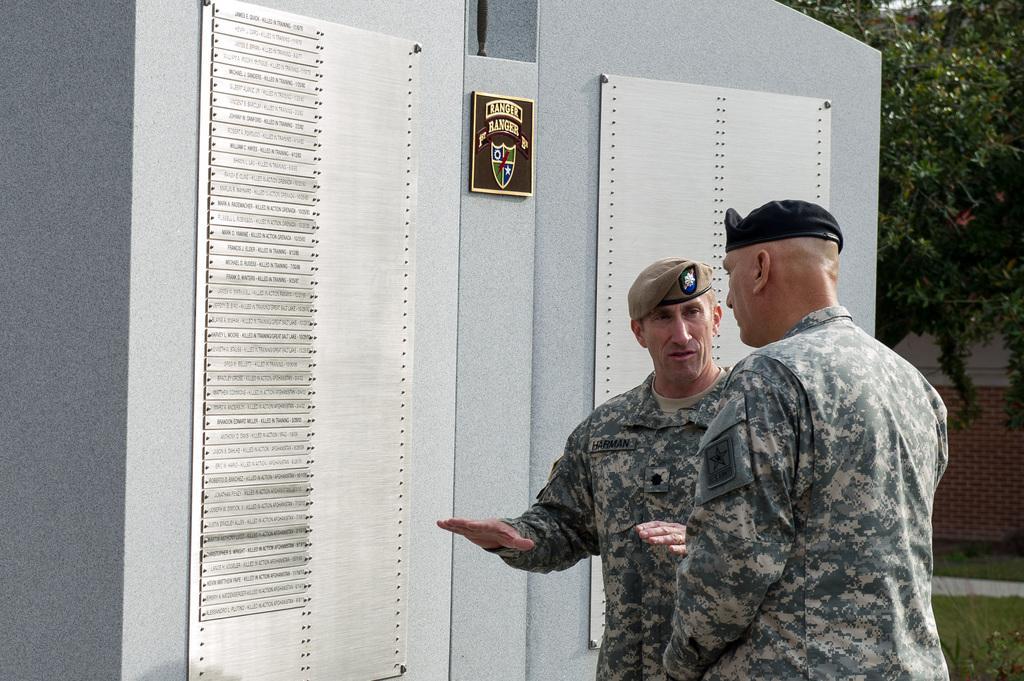How would you summarize this image in a sentence or two? In the foreground we can see two people talking. In the middle there is a wall, to which we can see two iron plates attached. On the right there are trees, plants, grass and wall. 